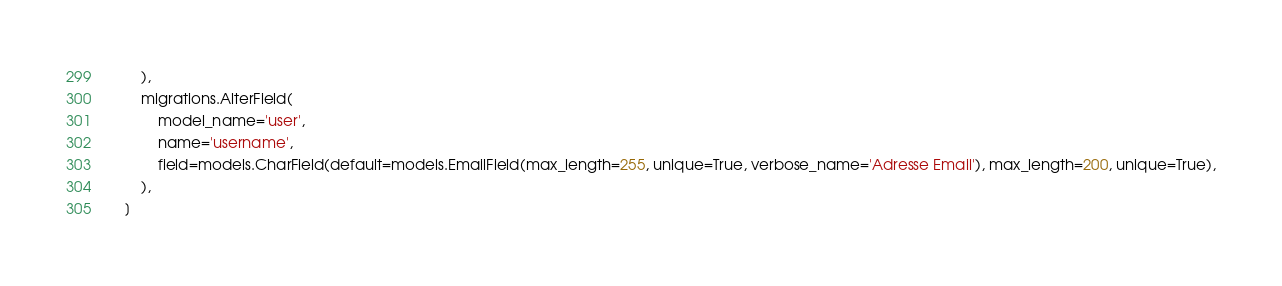Convert code to text. <code><loc_0><loc_0><loc_500><loc_500><_Python_>        ),
        migrations.AlterField(
            model_name='user',
            name='username',
            field=models.CharField(default=models.EmailField(max_length=255, unique=True, verbose_name='Adresse Email'), max_length=200, unique=True),
        ),
    ]
</code> 